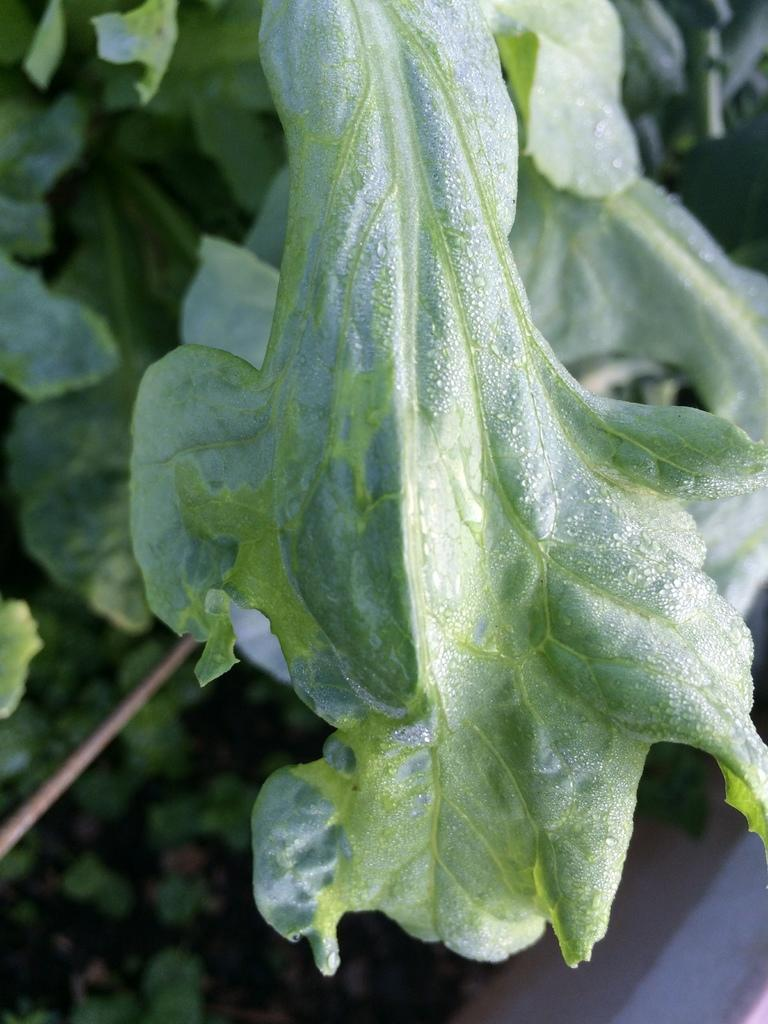What type of natural elements can be seen in the image? There are leaves in the image. Can you describe the leaves in the image? The leaves are likely from a tree or plant, and they may be green or have various shades of color. What might be the purpose of the leaves in the image? The leaves could be part of a decorative arrangement, or they might be naturally occurring in the environment where the image was taken. What type of coil is wrapped around the leaves in the image? There is no coil present in the image; it only features leaves. 